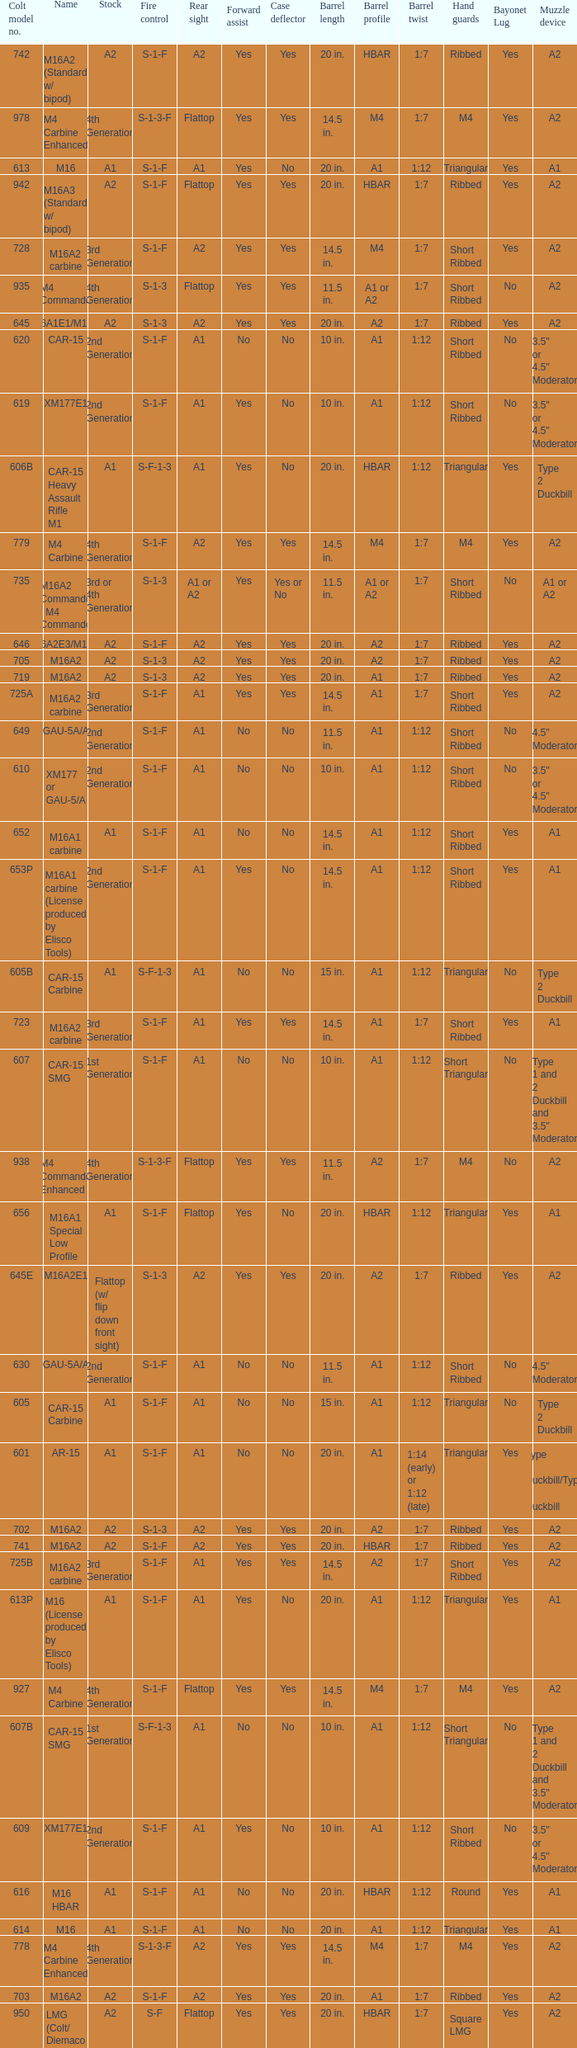What is the rear sight in the Cole model no. 735? A1 or A2. Could you help me parse every detail presented in this table? {'header': ['Colt model no.', 'Name', 'Stock', 'Fire control', 'Rear sight', 'Forward assist', 'Case deflector', 'Barrel length', 'Barrel profile', 'Barrel twist', 'Hand guards', 'Bayonet Lug', 'Muzzle device'], 'rows': [['742', 'M16A2 (Standard w/ bipod)', 'A2', 'S-1-F', 'A2', 'Yes', 'Yes', '20 in.', 'HBAR', '1:7', 'Ribbed', 'Yes', 'A2'], ['978', 'M4 Carbine Enhanced', '4th Generation', 'S-1-3-F', 'Flattop', 'Yes', 'Yes', '14.5 in.', 'M4', '1:7', 'M4', 'Yes', 'A2'], ['613', 'M16', 'A1', 'S-1-F', 'A1', 'Yes', 'No', '20 in.', 'A1', '1:12', 'Triangular', 'Yes', 'A1'], ['942', 'M16A3 (Standard w/ bipod)', 'A2', 'S-1-F', 'Flattop', 'Yes', 'Yes', '20 in.', 'HBAR', '1:7', 'Ribbed', 'Yes', 'A2'], ['728', 'M16A2 carbine', '3rd Generation', 'S-1-F', 'A2', 'Yes', 'Yes', '14.5 in.', 'M4', '1:7', 'Short Ribbed', 'Yes', 'A2'], ['935', 'M4 Commando', '4th Generation', 'S-1-3', 'Flattop', 'Yes', 'Yes', '11.5 in.', 'A1 or A2', '1:7', 'Short Ribbed', 'No', 'A2'], ['645', 'M16A1E1/M16A2', 'A2', 'S-1-3', 'A2', 'Yes', 'Yes', '20 in.', 'A2', '1:7', 'Ribbed', 'Yes', 'A2'], ['620', 'CAR-15', '2nd Generation', 'S-1-F', 'A1', 'No', 'No', '10 in.', 'A1', '1:12', 'Short Ribbed', 'No', '3.5" or 4.5" Moderator'], ['619', 'XM177E1', '2nd Generation', 'S-1-F', 'A1', 'Yes', 'No', '10 in.', 'A1', '1:12', 'Short Ribbed', 'No', '3.5" or 4.5" Moderator'], ['606B', 'CAR-15 Heavy Assault Rifle M1', 'A1', 'S-F-1-3', 'A1', 'Yes', 'No', '20 in.', 'HBAR', '1:12', 'Triangular', 'Yes', 'Type 2 Duckbill'], ['779', 'M4 Carbine', '4th Generation', 'S-1-F', 'A2', 'Yes', 'Yes', '14.5 in.', 'M4', '1:7', 'M4', 'Yes', 'A2'], ['735', 'M16A2 Commando / M4 Commando', '3rd or 4th Generation', 'S-1-3', 'A1 or A2', 'Yes', 'Yes or No', '11.5 in.', 'A1 or A2', '1:7', 'Short Ribbed', 'No', 'A1 or A2'], ['646', 'M16A2E3/M16A3', 'A2', 'S-1-F', 'A2', 'Yes', 'Yes', '20 in.', 'A2', '1:7', 'Ribbed', 'Yes', 'A2'], ['705', 'M16A2', 'A2', 'S-1-3', 'A2', 'Yes', 'Yes', '20 in.', 'A2', '1:7', 'Ribbed', 'Yes', 'A2'], ['719', 'M16A2', 'A2', 'S-1-3', 'A2', 'Yes', 'Yes', '20 in.', 'A1', '1:7', 'Ribbed', 'Yes', 'A2'], ['725A', 'M16A2 carbine', '3rd Generation', 'S-1-F', 'A1', 'Yes', 'Yes', '14.5 in.', 'A1', '1:7', 'Short Ribbed', 'Yes', 'A2'], ['649', 'GAU-5A/A', '2nd Generation', 'S-1-F', 'A1', 'No', 'No', '11.5 in.', 'A1', '1:12', 'Short Ribbed', 'No', '4.5" Moderator'], ['610', 'XM177 or GAU-5/A', '2nd Generation', 'S-1-F', 'A1', 'No', 'No', '10 in.', 'A1', '1:12', 'Short Ribbed', 'No', '3.5" or 4.5" Moderator'], ['652', 'M16A1 carbine', 'A1', 'S-1-F', 'A1', 'No', 'No', '14.5 in.', 'A1', '1:12', 'Short Ribbed', 'Yes', 'A1'], ['653P', 'M16A1 carbine (License produced by Elisco Tools)', '2nd Generation', 'S-1-F', 'A1', 'Yes', 'No', '14.5 in.', 'A1', '1:12', 'Short Ribbed', 'Yes', 'A1'], ['605B', 'CAR-15 Carbine', 'A1', 'S-F-1-3', 'A1', 'No', 'No', '15 in.', 'A1', '1:12', 'Triangular', 'No', 'Type 2 Duckbill'], ['723', 'M16A2 carbine', '3rd Generation', 'S-1-F', 'A1', 'Yes', 'Yes', '14.5 in.', 'A1', '1:7', 'Short Ribbed', 'Yes', 'A1'], ['607', 'CAR-15 SMG', '1st Generation', 'S-1-F', 'A1', 'No', 'No', '10 in.', 'A1', '1:12', 'Short Triangular', 'No', 'Type 1 and 2 Duckbill and 3.5" Moderator'], ['938', 'M4 Commando Enhanced', '4th Generation', 'S-1-3-F', 'Flattop', 'Yes', 'Yes', '11.5 in.', 'A2', '1:7', 'M4', 'No', 'A2'], ['656', 'M16A1 Special Low Profile', 'A1', 'S-1-F', 'Flattop', 'Yes', 'No', '20 in.', 'HBAR', '1:12', 'Triangular', 'Yes', 'A1'], ['645E', 'M16A2E1', 'Flattop (w/ flip down front sight)', 'S-1-3', 'A2', 'Yes', 'Yes', '20 in.', 'A2', '1:7', 'Ribbed', 'Yes', 'A2'], ['630', 'GAU-5A/A', '2nd Generation', 'S-1-F', 'A1', 'No', 'No', '11.5 in.', 'A1', '1:12', 'Short Ribbed', 'No', '4.5" Moderator'], ['605', 'CAR-15 Carbine', 'A1', 'S-1-F', 'A1', 'No', 'No', '15 in.', 'A1', '1:12', 'Triangular', 'No', 'Type 2 Duckbill'], ['601', 'AR-15', 'A1', 'S-1-F', 'A1', 'No', 'No', '20 in.', 'A1', '1:14 (early) or 1:12 (late)', 'Triangular', 'Yes', 'Type 1 Duckbill/Type 2 Duckbill'], ['702', 'M16A2', 'A2', 'S-1-3', 'A2', 'Yes', 'Yes', '20 in.', 'A2', '1:7', 'Ribbed', 'Yes', 'A2'], ['741', 'M16A2', 'A2', 'S-1-F', 'A2', 'Yes', 'Yes', '20 in.', 'HBAR', '1:7', 'Ribbed', 'Yes', 'A2'], ['725B', 'M16A2 carbine', '3rd Generation', 'S-1-F', 'A1', 'Yes', 'Yes', '14.5 in.', 'A2', '1:7', 'Short Ribbed', 'Yes', 'A2'], ['613P', 'M16 (License produced by Elisco Tools)', 'A1', 'S-1-F', 'A1', 'Yes', 'No', '20 in.', 'A1', '1:12', 'Triangular', 'Yes', 'A1'], ['927', 'M4 Carbine', '4th Generation', 'S-1-F', 'Flattop', 'Yes', 'Yes', '14.5 in.', 'M4', '1:7', 'M4', 'Yes', 'A2'], ['607B', 'CAR-15 SMG', '1st Generation', 'S-F-1-3', 'A1', 'No', 'No', '10 in.', 'A1', '1:12', 'Short Triangular', 'No', 'Type 1 and 2 Duckbill and 3.5" Moderator'], ['609', 'XM177E1', '2nd Generation', 'S-1-F', 'A1', 'Yes', 'No', '10 in.', 'A1', '1:12', 'Short Ribbed', 'No', '3.5" or 4.5" Moderator'], ['616', 'M16 HBAR', 'A1', 'S-1-F', 'A1', 'No', 'No', '20 in.', 'HBAR', '1:12', 'Round', 'Yes', 'A1'], ['614', 'M16', 'A1', 'S-1-F', 'A1', 'No', 'No', '20 in.', 'A1', '1:12', 'Triangular', 'Yes', 'A1'], ['778', 'M4 Carbine Enhanced', '4th Generation', 'S-1-3-F', 'A2', 'Yes', 'Yes', '14.5 in.', 'M4', '1:7', 'M4', 'Yes', 'A2'], ['703', 'M16A2', 'A2', 'S-1-F', 'A2', 'Yes', 'Yes', '20 in.', 'A1', '1:7', 'Ribbed', 'Yes', 'A2'], ['950', 'LMG (Colt/ Diemaco project)', 'A2', 'S-F', 'Flattop', 'Yes', 'Yes', '20 in.', 'HBAR', '1:7', 'Square LMG', 'Yes', 'A2'], ['610B', 'CAR-15 SMG', '2nd Generation', 'S-F-1-3', 'A1', 'No', 'No', '10 in.', 'A1', '1:12', 'Short Ribbed', 'No', '3.5" or 4.5" Moderator'], ['746', 'M16A2 (Standard w/ bipod)', 'A2', 'S-1-3', 'A2', 'Yes', 'Yes', '20 in.', 'HBAR', '1:7', 'Ribbed', 'Yes', 'A2'], ['713', 'M16A2', 'A2', 'S-1-3', 'A2', 'Yes', 'Yes', '20 in.', 'A2', '1:7', 'Ribbed', 'Yes', 'A2'], ['921', 'M4E1/A1 Carbine', '4th Generation', 'S-1-F', 'Flattop', 'Yes', 'Yes', '14.5 in.', 'M4', '1:7', 'M4', 'Yes', 'A2'], ['653', 'M16A1 carbine', '2nd Generation', 'S-1-F', 'A1', 'Yes', 'No', '14.5 in.', 'A1', '1:12', 'Short Ribbed', 'Yes', 'A1'], ['639', 'XM177E2', '2nd Generation', 'S-1-F', 'A1', 'Yes', 'No', '11.5 in.', 'A1', '1:12', 'Short Ribbed', 'No', '4.5" Moderator or A1'], ['603', 'XM16E1', 'A1', 'S-1-F', 'A1', 'Yes', 'No', '20 in.', 'A1', '1:12', 'Triangular', 'Yes', 'Type 2 Duckbill'], ['629', 'XM177E2', '2nd Generation', 'S-1-F', 'A1', 'Yes', 'No', '11.5 in.', 'A1', '1:12', 'Short Ribbed', 'No', '4.5" Moderator'], ['650', 'M16A1 carbine', 'A1', 'S-1-F', 'A1', 'Yes', 'No', '14.5 in.', 'A1', '1:12', 'Short Ribbed', 'Yes', 'A1'], ['635S', 'Colt SMG', '2nd Generation', 'S-1-F', 'A1', 'No', 'Yes', '10 in.', 'A1 w/ integral silencer', '1:10', 'Short Ribbed', 'No', 'A2'], ['750', 'LMG (Colt/ Diemaco project)', 'A2', 'S-F', 'A2', 'Yes', 'Yes', '20 in.', 'HBAR', '1:7', 'Square LMG', 'Yes', 'A2'], ['733A', 'M16A2 Commando / M4 Commando', '3rd or 4th Generation', 'S-1-3', 'A1 or A2', 'Yes', 'Yes or No', '11.5 in.', 'A1 or A2', '1:7', 'Short Ribbed', 'No', 'A1 or A2'], ['977', 'M4 Carbine', '4th Generation', 'S-1-3', 'Flattop', 'Yes', 'Yes', '14.5 in.', 'M4', '1:7', 'M4', 'Yes', 'A2'], ['606', 'CAR-15 Heavy Assault Rifle M1', 'A1', 'S-1-F', 'A1', 'No', 'No', '20 in.', 'HBAR', '1:12', 'Triangular', 'Yes', 'Type 2 Duckbill'], ['945', 'M16A2E4/M16A4', 'A2', 'S-1-3', 'Flattop', 'Yes', 'Yes', '20 in.', 'A2', '1:7', 'Ribbed', 'Yes', 'A2'], ['777', 'M4 Carbine', '4th Generation', 'S-1-3', 'A2', 'Yes', 'Yes', '14.5 in.', 'M4', '1:7', 'M4', 'Yes', 'A2'], ['604', 'M16 (No XM16 designation)', 'A1', 'S-1-F', 'A1', 'No', 'No', '20 in.', 'A1', '1:12', 'Triangular', 'Yes', 'A1'], ['979', 'M4A1 Carbine', '4th Generation', 'S-1-F', 'Flattop', 'Yes', 'Yes', '14.5 in.', 'M4', '1:7', 'M4', 'Yes', 'A2'], ['603', 'M16A1', 'A1', 'S-1-F', 'A1', 'Yes', 'No', '20 in.', 'A1', '1:12', 'Triangular', 'Yes', 'A1'], ['920', 'M4 Carbine', '3rd and 4th Generation', 'S-1-3', 'Flattop', 'Yes', 'Yes', '14.5 in.', 'M4', '1:7', 'M4', 'Yes', 'A2'], ['727', 'M16A2 carbine', '3rd Generation', 'S-1-F', 'A2', 'Yes', 'Yes', '14.5 in.', 'M4', '1:7', 'Short Ribbed', 'Yes', 'A2'], ['606A', 'CAR-15 Heavy Assault Rifle M1', 'A1', 'S-1-F', 'A1', 'Yes', 'No', '20 in.', 'HBAR', '1:12', 'Triangular', 'Yes', 'Type 2 Duckbill'], ['726', 'M16A2 carbine', '3rd Generation', 'S-1-F', 'A1', 'Yes', 'Yes', '14.5 in.', 'A1', '1:7', 'Short Ribbed', 'Yes', 'A1'], ['611P', 'M16 HBAR (License produced by Elisco Tools)', 'A1', 'S-1-F', 'A1', 'Yes', 'No', '20 in.', 'HBAR', '1:12', 'Triangular', 'Yes', 'A1'], ['701', 'M16A2', 'A2', 'S-1-F', 'A2', 'Yes', 'Yes', '20 in.', 'A2', '1:7', 'Ribbed', 'Yes', 'A2'], ['901', 'M16A3', 'A2', 'S-1-F', 'Flattop', 'Yes', 'Yes', '20 in.', 'A2', '1:7', 'Ribbed', 'Yes', 'A2'], ['925', 'M4E2 Carbine', '3rd or 4th Generation', 'S-1-3', 'Flattop', 'Yes', 'Yes', '14.5 in.', 'M4', '1:7', 'M4', 'Yes', 'A2'], ['738', 'M4 Commando Enhanced', '4th Generation', 'S-1-3-F', 'A2', 'Yes', 'Yes', '11.5 in.', 'A2', '1:7', 'Short Ribbed', 'No', 'A1 or A2'], ['615', 'M16 HBAR', 'A1', 'S-1-F', 'A1', 'No', 'No', '20 in.', 'HBAR', '1:12', 'Triangular', 'Yes', 'A1'], ['921HB', 'M4A1 Carbine', '4th Generation', 'S-1-F', 'Flattop', 'Yes', 'Yes', '14.5 in.', 'M4 HBAR', '1:7', 'M4', 'Yes', 'A2'], ['634', 'Colt SMG', '2nd Generation', 'Conflict between S-1 and S-1-F', 'A1', 'No', 'Yes', '10 in.', 'A1', '1:10', 'Short Ribbed', 'No', 'A2'], ['720', 'XM4 Carbine', '3rd Generation', 'S-1-3', 'A2', 'Yes', 'Yes', '14.5 in.', 'M4', '1:7', 'Short Ribbed', 'Yes', 'A2'], ['651', 'M16A1 carbine', 'A1', 'S-1-F', 'A1', 'Yes', 'No', '14.5 in.', 'A1', '1:12', 'Short Ribbed', 'Yes', 'A1'], ['"977"', 'M4 Carbine', '4th Generation', 'S-1-3', 'Flattop', 'Yes', 'Yes', '14.5 in.', 'M4', '1:7', 'M4', 'Yes', 'A2'], ['608', 'CAR-15 Survival Rifle', 'Tubular', 'S-1-F', 'A1', 'No', 'No', '10 in.', 'A1', '1:12', 'Short Round', 'No', 'Conical or 3.5" Moderator'], ['734A', 'M16A2 Commando', '3rd Generation', 'S-1-3', 'A1 or A2', 'Yes', 'Yes or No', '11.5 in.', 'A1 or A2', '1:7', 'Short Ribbed', 'No', 'A1 or A2'], ['734', 'M16A2 Commando', '3rd Generation', 'S-1-F', 'A1 or A2', 'Yes', 'Yes or No', '11.5 in.', 'A1 or A2', '1:7', 'Short Ribbed', 'No', 'A1 or A2'], ['602', 'AR-15', 'A1', 'S-1-F', 'A1', 'No', 'No', '20 in.', 'A1', '1:12', 'Triangular', 'Yes', 'Type 2 Duckbill'], ['933', 'M4 Commando', '4th Generation', 'S-1-F', 'Flattop', 'Yes', 'Yes', '11.5 in.', 'A1 or A2', '1:7', 'Short Ribbed', 'No', 'A2'], ['640', 'XM177E2', '2nd Generation', 'S-1-F', 'A1', 'No', 'No', '11.5 in.', 'A1', '1:12', 'Short Ribbed', 'No', '4.5" Moderator or A1'], ['707', 'M16A2', 'A2', 'S-1-3', 'A2', 'Yes', 'Yes', '20 in.', 'A1', '1:7', 'Ribbed', 'Yes', 'A2'], ['605A', 'CAR-15 Carbine', 'A1', 'S-1-F', 'A1', 'Yes', 'No', '15 in.', 'A1', '1:12', 'Triangular', 'No', 'Type 2 Duckbill'], ['745', 'M16A2 (Standard w/ bipod)', 'A2', 'S-1-3', 'A2', 'Yes', 'Yes', '20 in.', 'HBAR', '1:7', 'Ribbed', 'Yes', 'A2'], ['733', 'M16A2 Commando / M4 Commando', '3rd or 4th Generation', 'S-1-F', 'A1 or A2', 'Yes', 'Yes or No', '11.5 in.', 'A1 or A2', '1:7', 'Short Ribbed', 'No', 'A1 or A2'], ['635', 'Colt SMG', '2nd, 3rd, or 4th Generation', 'S-1-F', 'A1', 'No', 'Yes', '10 in.', 'A1', '1:10', 'Short Ribbed', 'No', 'A2'], ['611', 'M16 HBAR', 'A1', 'S-1-F', 'A1', 'Yes', 'No', '20 in.', 'HBAR', '1:12', 'Triangular', 'Yes', 'A1'], ['905', 'M16A4', 'A2', 'S-1-3', 'Flattop', 'Yes', 'Yes', '20 in.', 'A2', '1:7', 'Ribbed', 'Yes', 'A2'], ['607A', 'CAR-15 SMG', '1st Generation', 'S-1-F', 'A1', 'Yes', 'No', '10 in.', 'A1', '1:12', 'Short Triangular', 'No', 'Type 1 and 2 Duckbill and 3.5" Moderator'], ['633', 'Colt SMG', '2nd Generation', 'S-1-F', 'A1', 'No', 'Yes', '7 in.', 'A1', '1:10', 'Short Round', 'No', 'None'], ['654', 'M16A1 carbine', '2nd Generation', 'S-1-F', 'A1', 'No', 'No', '14.5 in.', 'A1', '1:12', 'Short Ribbed', 'Yes', 'A1'], ['737', 'M16A2', 'A2', 'S-1-3', 'A2', 'Yes', 'Yes', '20 in.', 'HBAR', '1:7', 'Ribbed', 'Yes', 'A2'], ['639', 'Colt SMG', '2nd', 'S-1-3', 'A1', 'No', 'Yes', '10 in.', 'A1 w/ integral silencer', '1:10', 'Short Ribbed', 'No', 'A2'], ['621', 'M16A1 HBAR', 'A1', 'S-1-F', 'A1', 'Yes', 'No', '20 in.', 'HBAR', '1:12', 'Triangular', 'Yes', 'A1'], ['711', 'M16A2', 'A2', 'S-1-F', 'A1', 'Yes', 'No and Yes', '20 in.', 'A1', '1:7', 'Ribbed', 'Yes', 'A2'], ['941', 'M16A3', 'A2', 'S-1-F', 'Flattop', 'Yes', 'Yes', '20 in.', 'HBAR', '1:7', 'Ribbed', 'Yes', 'A2']]} 